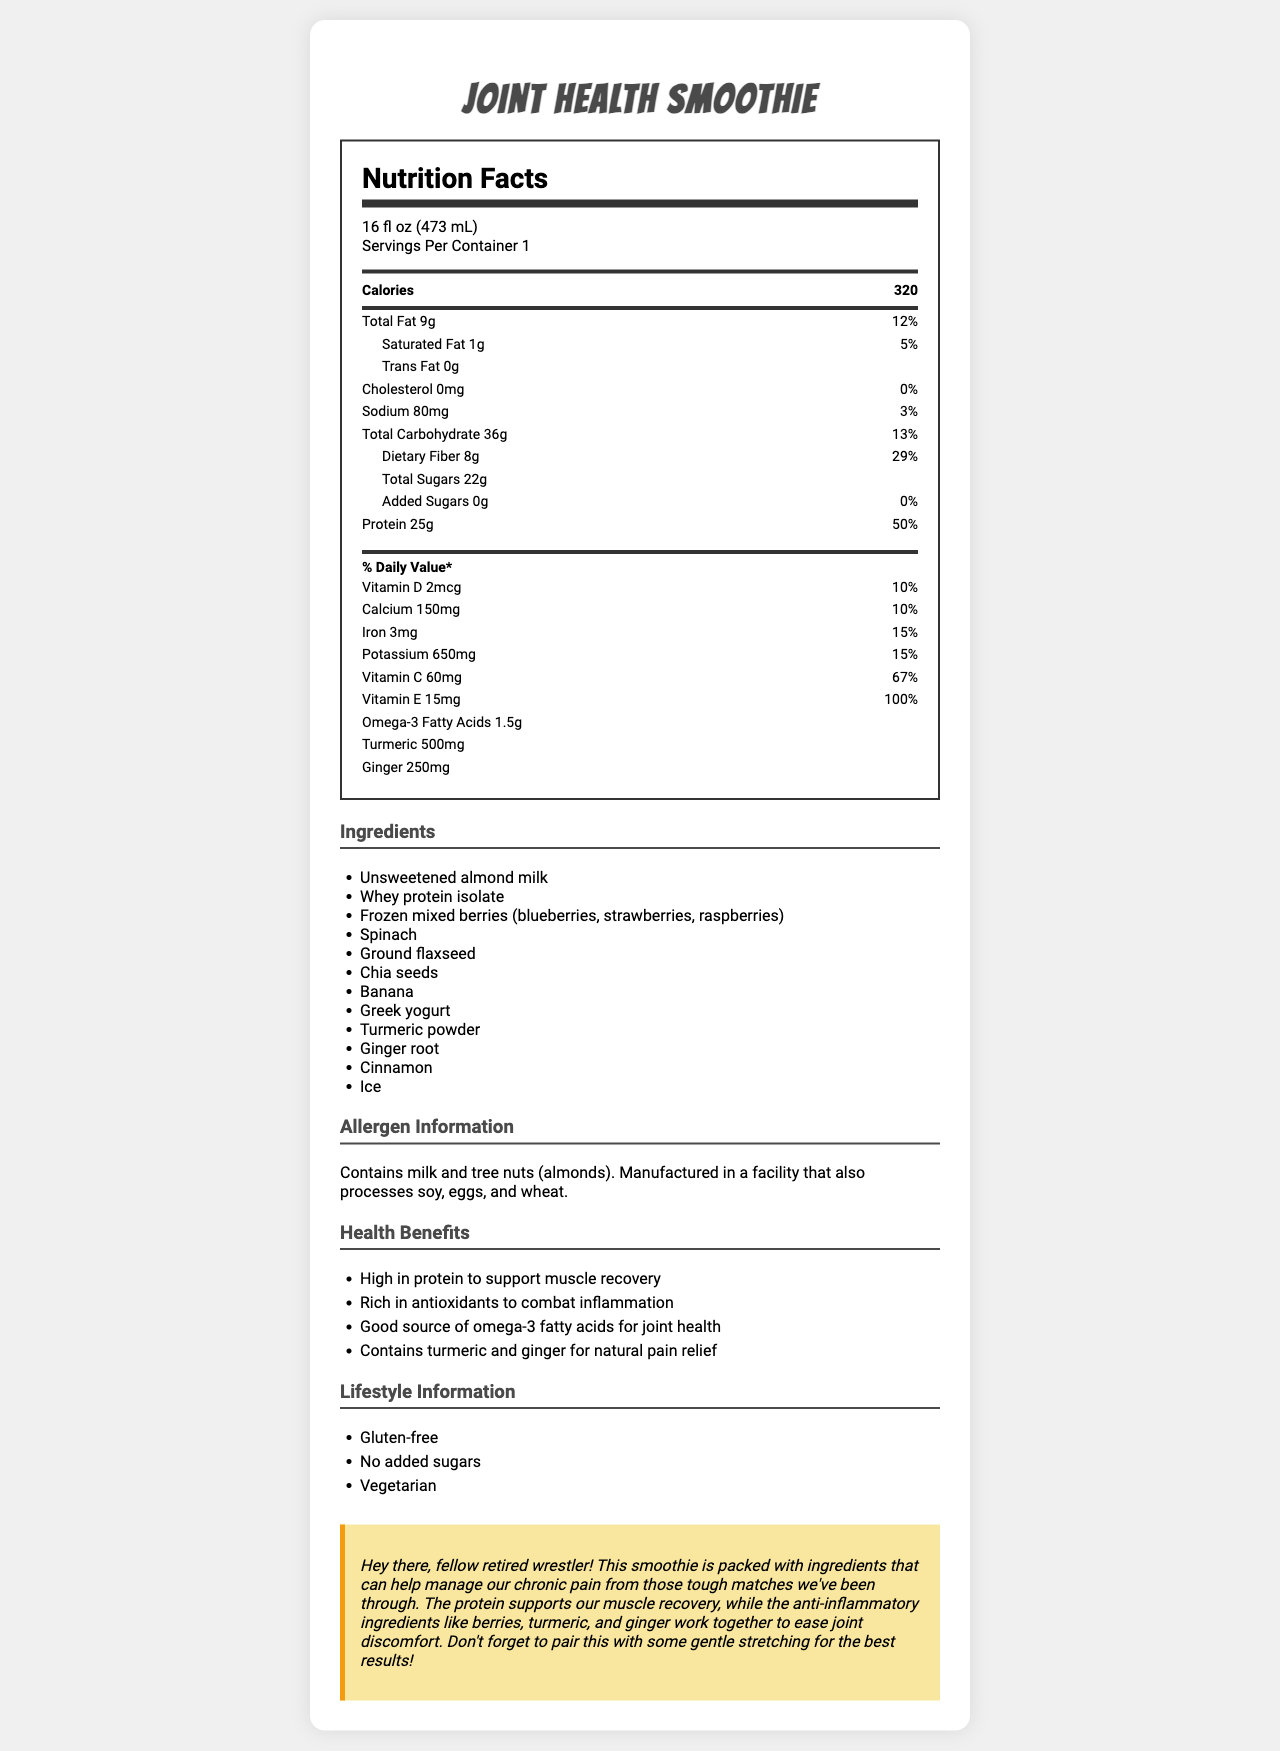who would benefit from this smoothie? The health claims indicate that the smoothie is high in protein for muscle recovery, rich in antioxidants to combat inflammation, contains omega-3 fatty acids for joint health, and includes turmeric and ginger for natural pain relief.
Answer: People looking for muscle recovery and joint health, especially those managing chronic pain what is the serving size of this smoothie? It is stated in the serving info section at the top of the nutrition label.
Answer: 16 fl oz (473 mL) how many calories are in one serving of the smoothie? This value is displayed prominently in the macro-nutrient section of the nutrition label.
Answer: 320 list two key anti-inflammatory ingredients in the smoothie These ingredients are listed at the bottom of the nutrient section in the nutrition label.
Answer: Turmeric, Ginger what is the amount of protein per serving? The protein amount is listed, along with its daily value percentage, on the nutrition label.
Answer: 25g does the smoothie contain any dietary fiber? The nutrition label indicates that there is 8g of dietary fiber per serving, which is 29% of the daily value.
Answer: Yes how much vitamin C does the smoothie provide? The nutrition label lists vitamin C content along with its daily value percentage.
Answer: 60mg which of the following health benefits is mentioned in the document?
A. Lowers blood pressure
B. Supports muscle recovery
C. Improves vision
D. Enhances brain function The health claims section states that the smoothie is high in protein to support muscle recovery.
Answer: B. Supports muscle recovery which ingredient is NOT in the smoothie?
1. Spinach
2. Kale
3. Greek yogurt
4. Whey protein isolate Kale is not listed in the ingredients section; spinach is included instead.
Answer: 2. Kale does the smoothie contain any gluten? The document explicitly mentions in the lifestyle information that the smoothie is gluten-free.
Answer: No what allergens are present in this smoothie? The allergen information section lists milk and tree nuts (almonds) as allergens.
Answer: Milk and tree nuts (almonds) summarize the main idea of the document This summary captures the essence of the document, including its purpose, key nutritional information, and specific benefits related to joint health and muscle recovery.
Answer: The document provides a detailed nutrition facts label for a high-protein, anti-inflammatory smoothie designed for joint health. It lists the serving size, calorie count, nutrient content, ingredients, allergens, health benefits, and lifestyle info. The smoothie supports muscle recovery and joint health with ingredients such as whey protein, berries, turmeric, and ginger. It is gluten-free, vegetarian, and contains no added sugars. what is the source of omega-3 fatty acids in the smoothie? The document does not specify which ingredient provides the omega-3 fatty acids; it only lists the total amount of omega-3s in the nutrient section.
Answer: Cannot be determined 